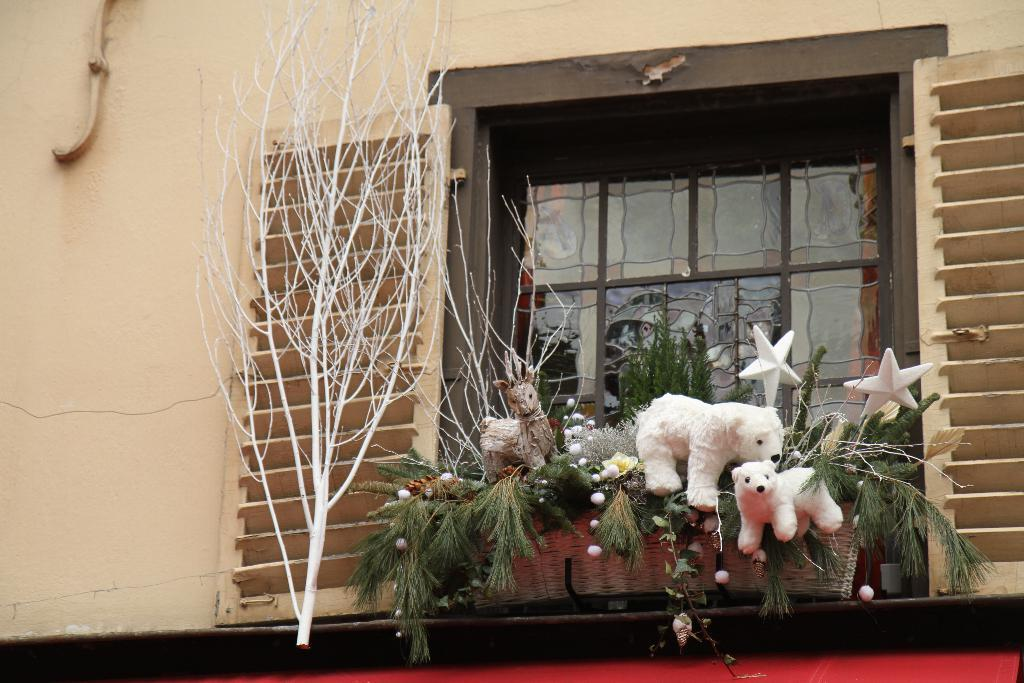What can be seen in the image that provides a view of the outdoors? There is a window in the image that provides a view of the outdoors. What is located near the window in the image? There is a wall to the left of the window. What is inside the window in the image? There are plants and two dolls among the plants in the window. What organization is responsible for maintaining the bushes outside the window in the image? There are no bushes visible in the image, only plants inside the window. 